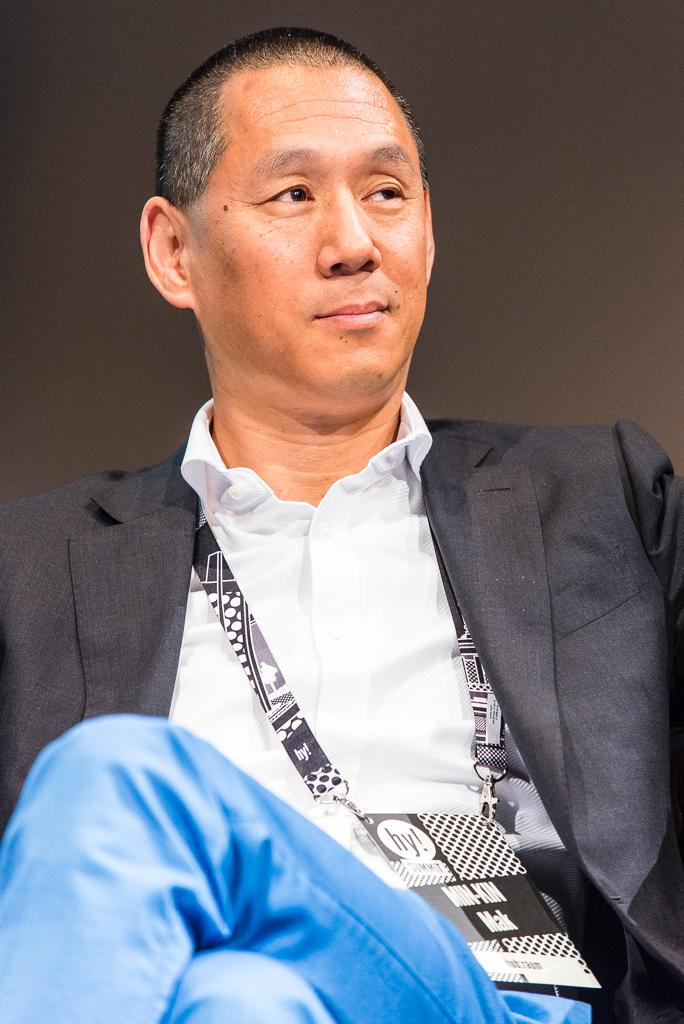What is the main subject of the image? There is a man sitting in the center of the image. What is the man wearing? The man is wearing a suit. What can be seen in the background of the image? There is a wall in the background of the image. What type of thrill can be seen in the man's eyes in the image? There is no indication of a thrill or any specific emotion in the man's eyes in the image. 